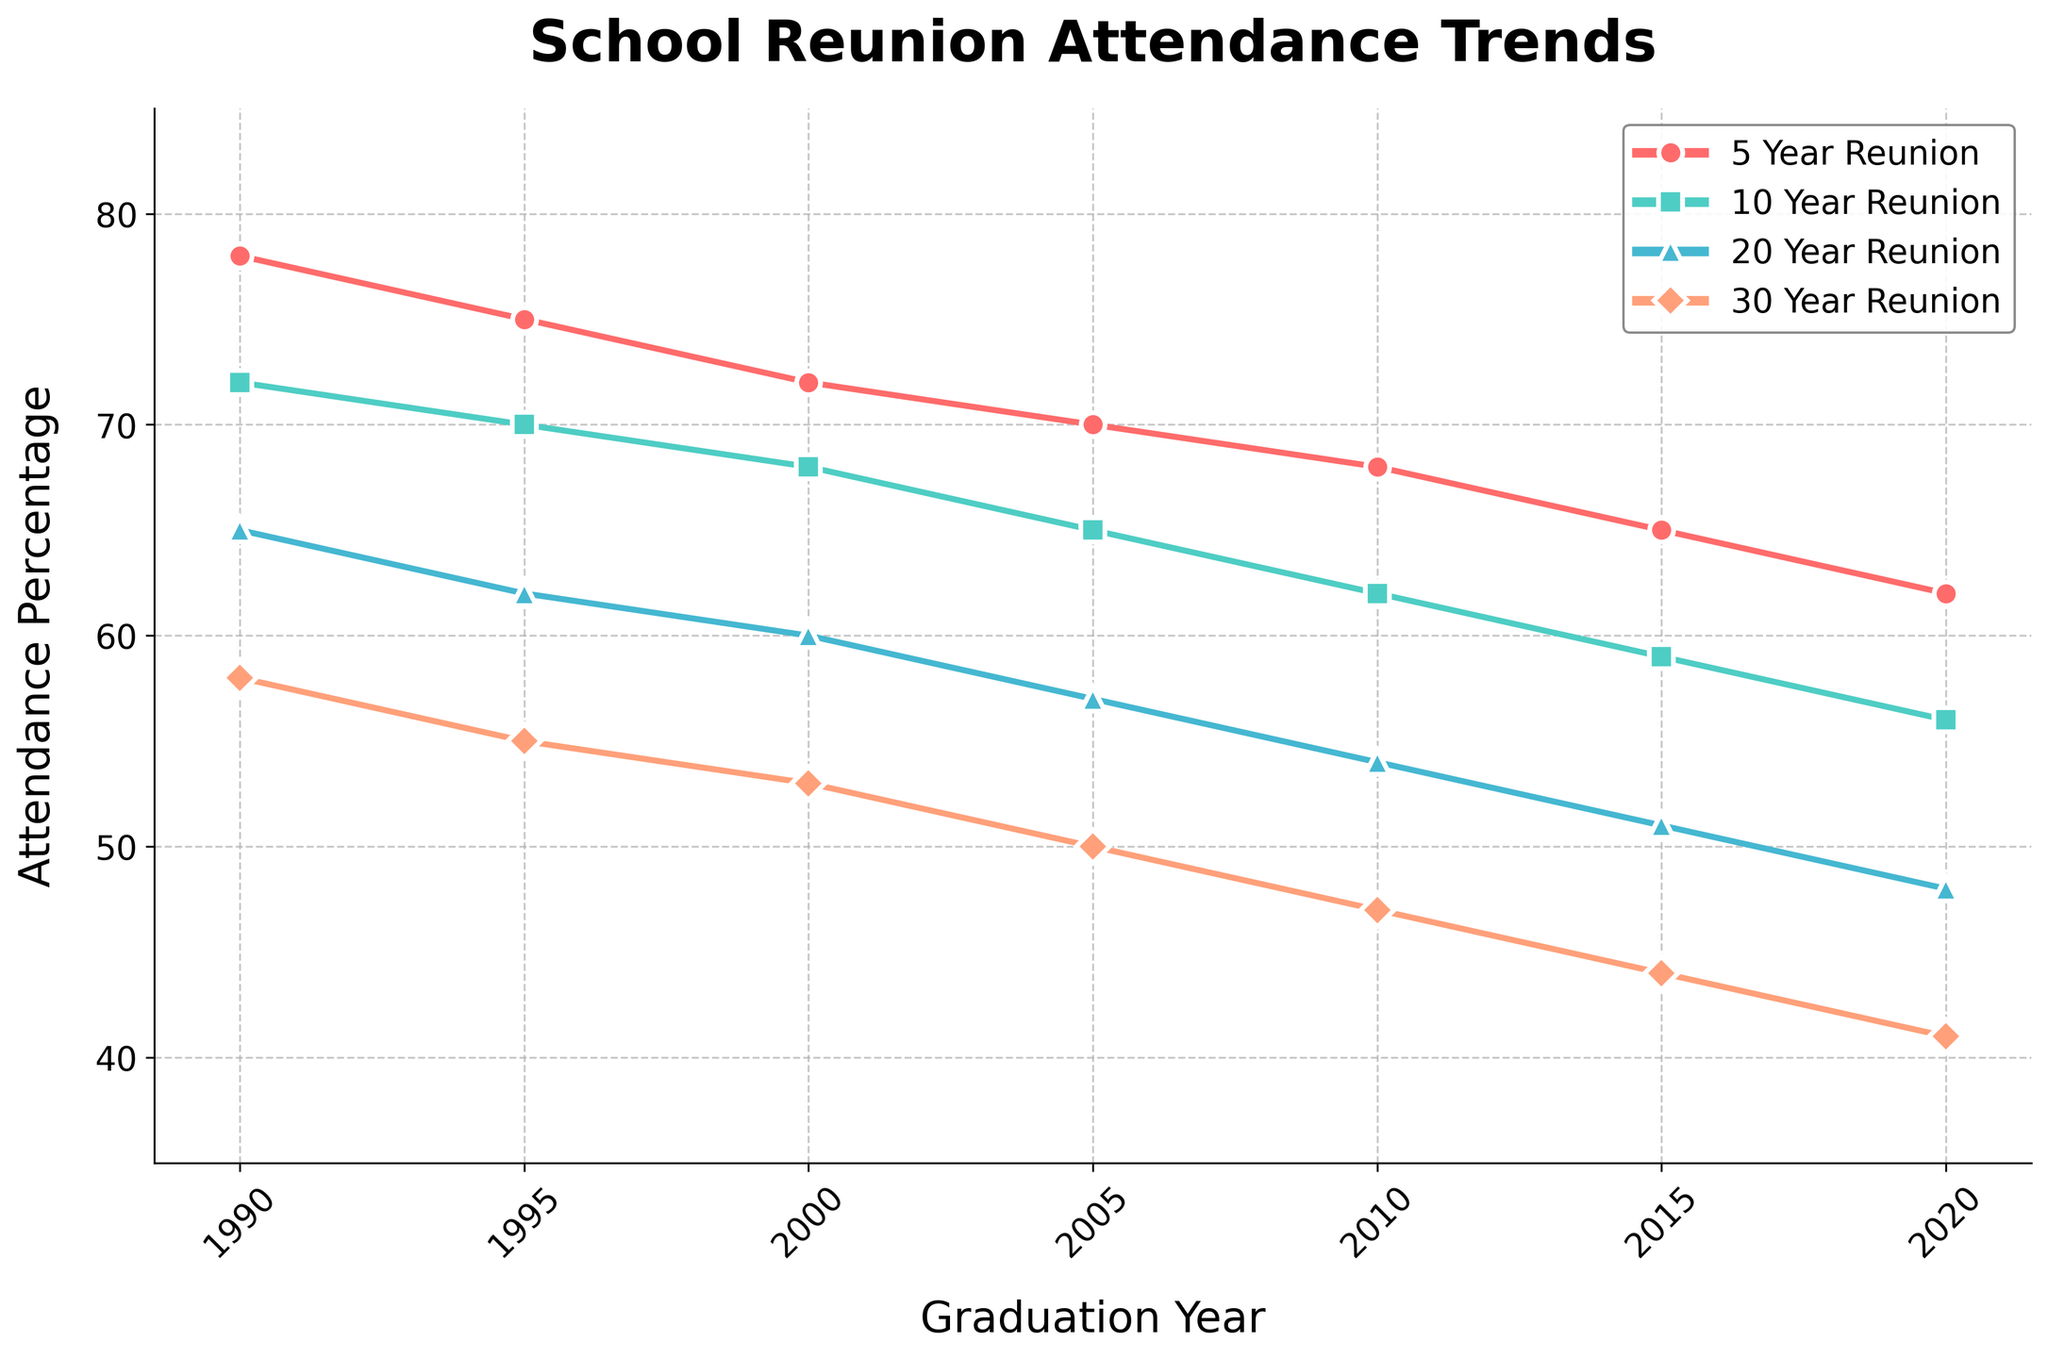What's the attendance percentage for the 5 Year Reunion for those who graduated in 2005? First, locate the 5 Year Reunion line on the plot, which is marked with circles. Then find the point where this line intersects with the graduation year 2005 on the x-axis. The corresponding y-value is 70%.
Answer: 70% Which reunion year had the highest attendance percentage for the class of 1990? Inspect the attendance percentages for the class of 1990 on the figure. The highest value among them is 5 Year Reunion with 78%.
Answer: 5 Year Reunion How does the attendance for the 10 Year Reunion compare between graduates of 2010 and 1995? Find the positions of the 10 Year Reunion line (marked with squares) at the graduation years 2010 and 1995. For 2010, it's 62%; for 1995, it's 70%. Thus, the attendance percentage for 1995 is higher than for 2010.
Answer: 1995 has higher attendance What is the average attendance percentage for the 30 Year Reunion across all years? List the attendance for the 30 Year Reunion from the figure: 58%, 55%, 53%, 50%, 47%, 44%, and 41%. Sum these percentages: 58 + 55 + 53 + 50 + 47 + 44 + 41 = 348. There are 7 data points, so the average is 348 / 7 = 49.71
Answer: 49.71% Did attendance for the 20 Year Reunion decrease or increase over time for graduates from 2000 to 2020? Check the 20 Year Reunion attendance percentages for the years 2000 (60%) and 2020 (48%). Since 48% < 60%, the attendance decreased over this period.
Answer: Decrease Among all reunion years, which particular reunion has the steepest decline in attendance over time? Compare the slopes of the lines for 5 Year, 10 Year, 20 Year, and 30 Year Reunions. The 5 Year Reunion line has the steepest decline, starting at 78% in 1990 and dropping to 62% in 2020, a total drop of 16 percentage points.
Answer: 5 Year Reunion Is the decline in attendance for the 30 Year Reunion consistent across all graduation years? Observe the line representing the 30 Year Reunion. The decline appears to be consistent and gradual across all graduation years, descending almost linearly from 58% in 1990 to 41% in 2020.
Answer: Yes What's the difference in attendance percentage between the 5 Year and 30 Year Reunions for the class of 2000? Find the 5 Year and 30 Year attendance percentages for 2000 (72% and 53%, respectively) and subtract the latter from the former: 72% - 53% = 19%.
Answer: 19% What visual attribute distinguishes the 20 Year Reunion line from the others in the plot? The 20 Year Reunion line is marked by triangles, which visually separate it from the other reunion lines.
Answer: Triangles 